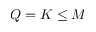Convert formula to latex. <formula><loc_0><loc_0><loc_500><loc_500>Q = K \leq M</formula> 